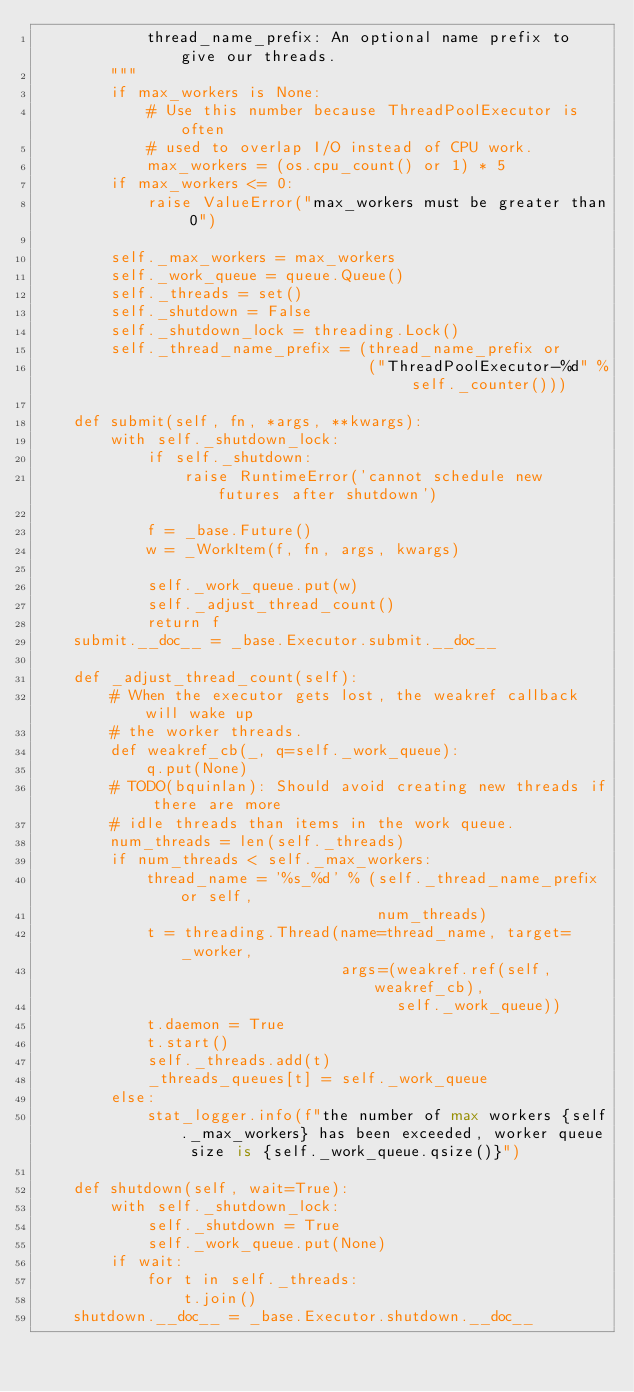<code> <loc_0><loc_0><loc_500><loc_500><_Python_>            thread_name_prefix: An optional name prefix to give our threads.
        """
        if max_workers is None:
            # Use this number because ThreadPoolExecutor is often
            # used to overlap I/O instead of CPU work.
            max_workers = (os.cpu_count() or 1) * 5
        if max_workers <= 0:
            raise ValueError("max_workers must be greater than 0")

        self._max_workers = max_workers
        self._work_queue = queue.Queue()
        self._threads = set()
        self._shutdown = False
        self._shutdown_lock = threading.Lock()
        self._thread_name_prefix = (thread_name_prefix or
                                    ("ThreadPoolExecutor-%d" % self._counter()))

    def submit(self, fn, *args, **kwargs):
        with self._shutdown_lock:
            if self._shutdown:
                raise RuntimeError('cannot schedule new futures after shutdown')

            f = _base.Future()
            w = _WorkItem(f, fn, args, kwargs)

            self._work_queue.put(w)
            self._adjust_thread_count()
            return f
    submit.__doc__ = _base.Executor.submit.__doc__

    def _adjust_thread_count(self):
        # When the executor gets lost, the weakref callback will wake up
        # the worker threads.
        def weakref_cb(_, q=self._work_queue):
            q.put(None)
        # TODO(bquinlan): Should avoid creating new threads if there are more
        # idle threads than items in the work queue.
        num_threads = len(self._threads)
        if num_threads < self._max_workers:
            thread_name = '%s_%d' % (self._thread_name_prefix or self,
                                     num_threads)
            t = threading.Thread(name=thread_name, target=_worker,
                                 args=(weakref.ref(self, weakref_cb),
                                       self._work_queue))
            t.daemon = True
            t.start()
            self._threads.add(t)
            _threads_queues[t] = self._work_queue
        else:
            stat_logger.info(f"the number of max workers {self._max_workers} has been exceeded, worker queue size is {self._work_queue.qsize()}")

    def shutdown(self, wait=True):
        with self._shutdown_lock:
            self._shutdown = True
            self._work_queue.put(None)
        if wait:
            for t in self._threads:
                t.join()
    shutdown.__doc__ = _base.Executor.shutdown.__doc__</code> 